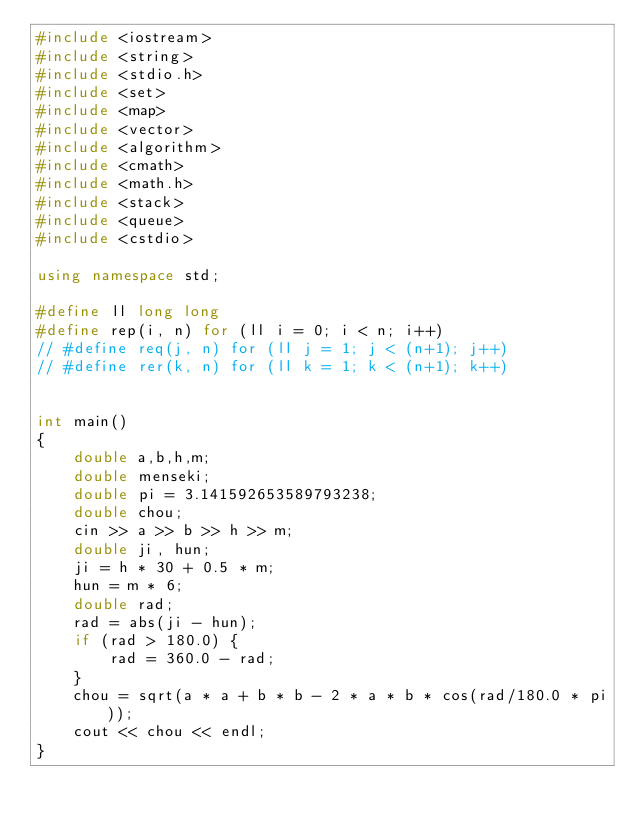<code> <loc_0><loc_0><loc_500><loc_500><_C++_>#include <iostream>
#include <string>
#include <stdio.h>
#include <set>
#include <map>
#include <vector>
#include <algorithm>
#include <cmath>
#include <math.h>
#include <stack>
#include <queue>
#include <cstdio>

using namespace std;

#define ll long long
#define rep(i, n) for (ll i = 0; i < n; i++)
// #define req(j, n) for (ll j = 1; j < (n+1); j++)
// #define rer(k, n) for (ll k = 1; k < (n+1); k++)


int main()
{
    double a,b,h,m;
    double menseki;
    double pi = 3.141592653589793238;
    double chou;
    cin >> a >> b >> h >> m;
    double ji, hun;
    ji = h * 30 + 0.5 * m;
    hun = m * 6;
    double rad;
    rad = abs(ji - hun);
    if (rad > 180.0) {
        rad = 360.0 - rad;
    }
    chou = sqrt(a * a + b * b - 2 * a * b * cos(rad/180.0 * pi));
    cout << chou << endl;
}</code> 